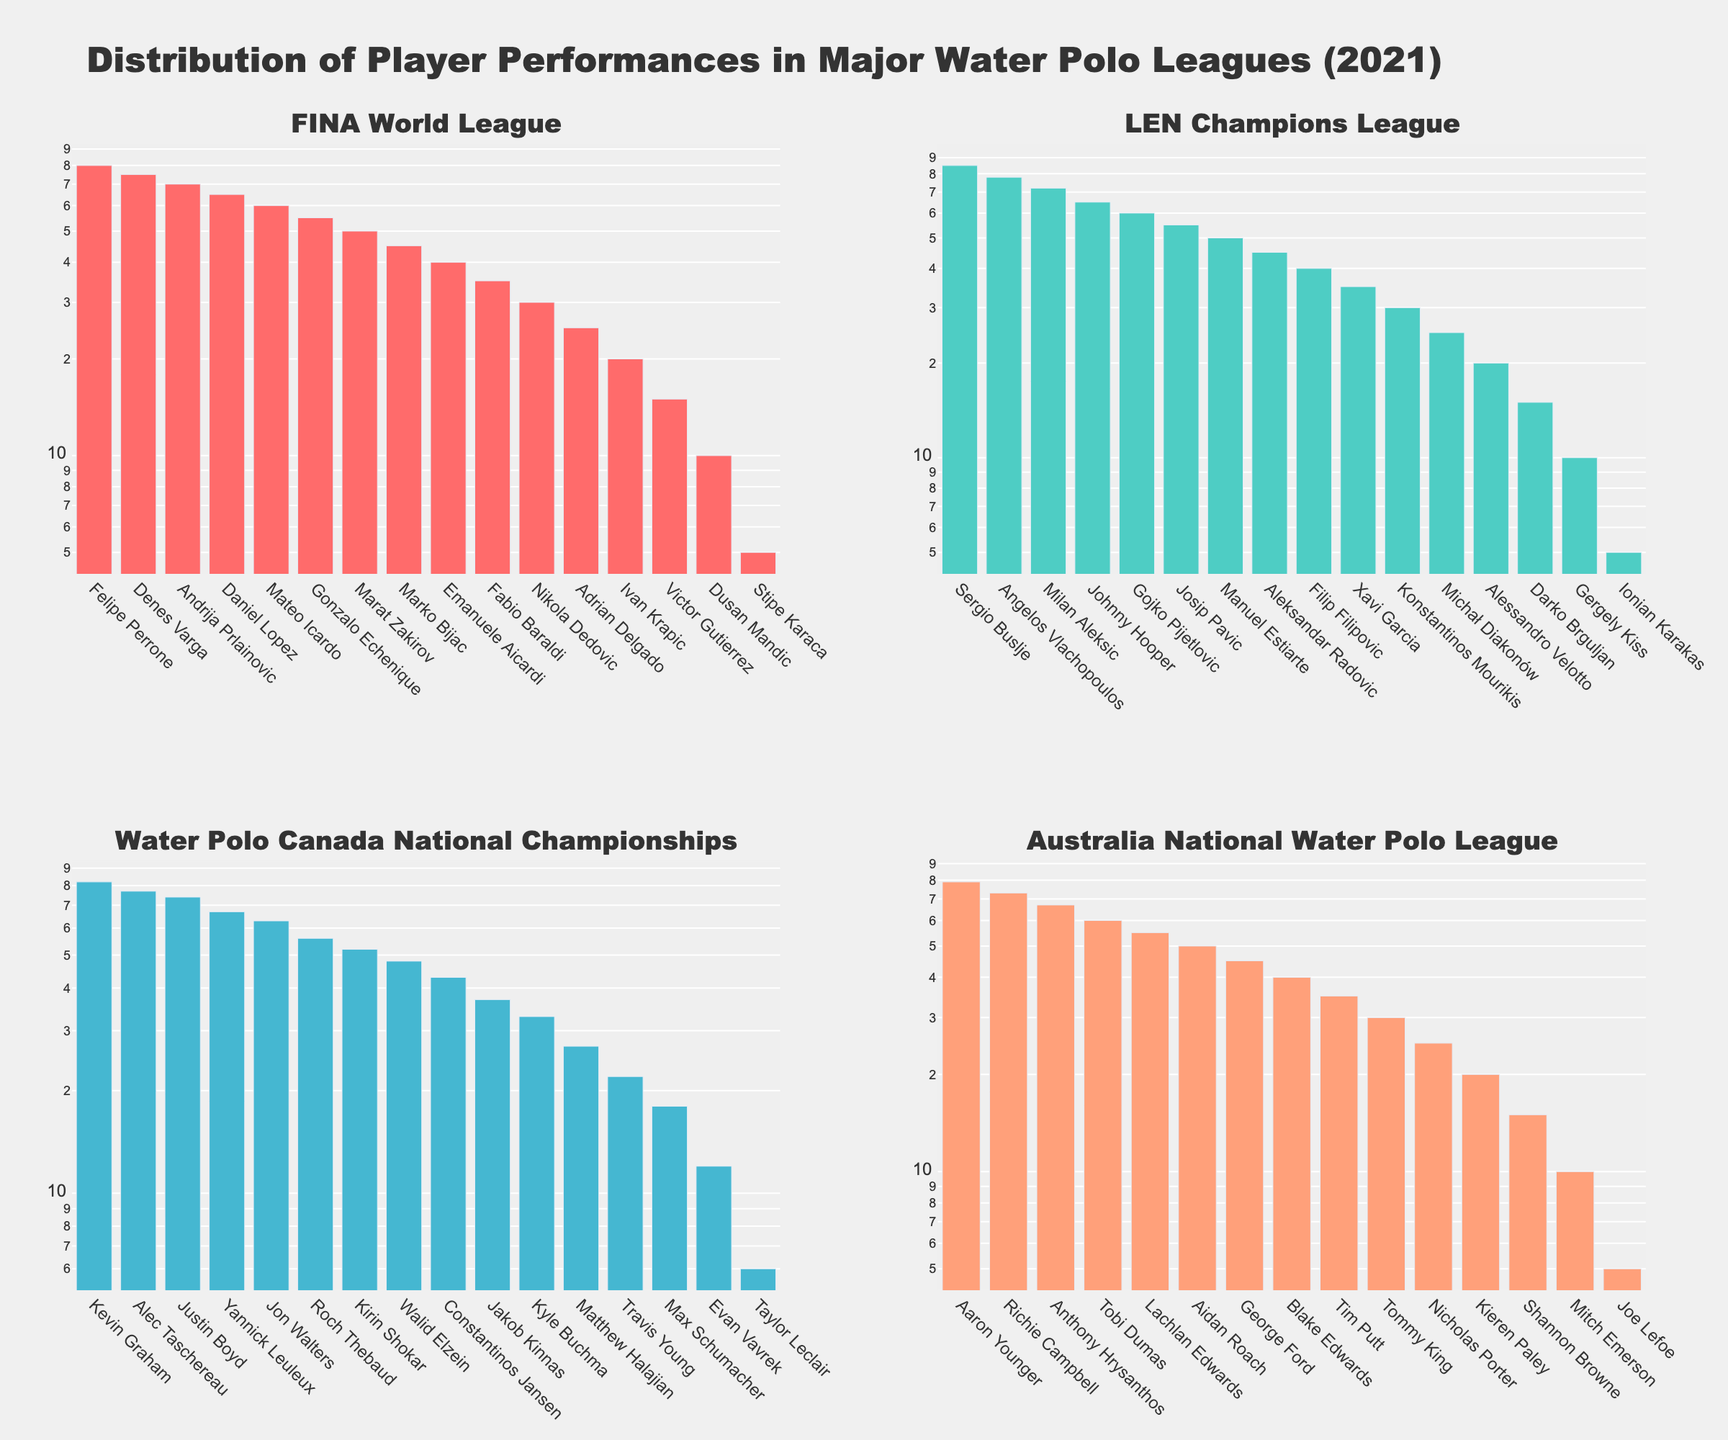What is the title of the figure? The title of the figure is positioned at the top and clearly states the main focus of the plot. It reads "Distribution of Player Performances in Major Water Polo Leagues (2021)"
Answer: Distribution of Player Performances in Major Water Polo Leagues (2021) Which league has the highest-scoring player? To find the highest-scoring player across all leagues, we identify the subplot with the highest bar length on the y-axis. The subplot for the LEN Champions League has Sergio Buslje with the highest goal count of 85.
Answer: LEN Champions League How many players from the FINA World League scored more than 50 goals? Observe the subplot for the FINA World League and count the number of bars that exceed the 50-goal mark by noting the y-axis scale. There are 4 players who scored more than 50 goals.
Answer: 4 players Which league has the player with the least number of goals? Find the player with the smallest bar length in each subplot and compare their goal counts. This is seen in all leagues with several players scoring 5 goals each, but the lowest seem consistent across all leagues.
Answer: All leagues have players with 5 goals Compare the median number of goals for players in the FINA World League and Water Polo Canada National Championships. Which league has a higher median? Calculate the median by identifying the middle value when the goals are arranged in descending order. For FINA, it's the middle score between 40 and 35 which is 38. For Canada, it's the middle score between 37 and 33 which is 35. The FINA World League's median is higher.
Answer: FINA World League What is the color used for the Australia's National Water Polo League bars? The colors of the bars are distinguishable by their unique shades. Australia's National Water Polo League bars are colored light salmon.
Answer: Light salmon Which two players scored the closest number of goals in the LEN Champions League? By closely examining the bars in the LEN Champions League subplot, Josip Pavic and Manuel Estiarte have very close goal counts, 55 and 50 respectively, making them the closest in scores within a narrow margin of 5 goals.
Answer: Josip Pavic and Manuel Estiarte What is the difference in goals between the highest-scoring player in the FINA World League and the highest-scoring player in the LEN Champions League? The highest-scoring player in the FINA World League is Felipe Perrone with 80 goals, and in the LEN Champions League, it is Sergio Buslje with 85 goals. The difference is calculated as 85 - 80.
Answer: 5 goals How many subplots are there in the figure, and what does each represent? Count the number of different sections in the figure and note their titles. There are 4 subplots, each representing the FINA World League, LEN Champions League, Water Polo Canada National Championships, and Australia's National Water Polo League.
Answer: 4 subplots Which league shows the smallest range of goals among its players? Evaluate the range of goals by looking at the highest and lowest values in each subplot. The Australia National Water Polo League has the smallest range from 79 to 5.
Answer: Australia National Water Polo League 